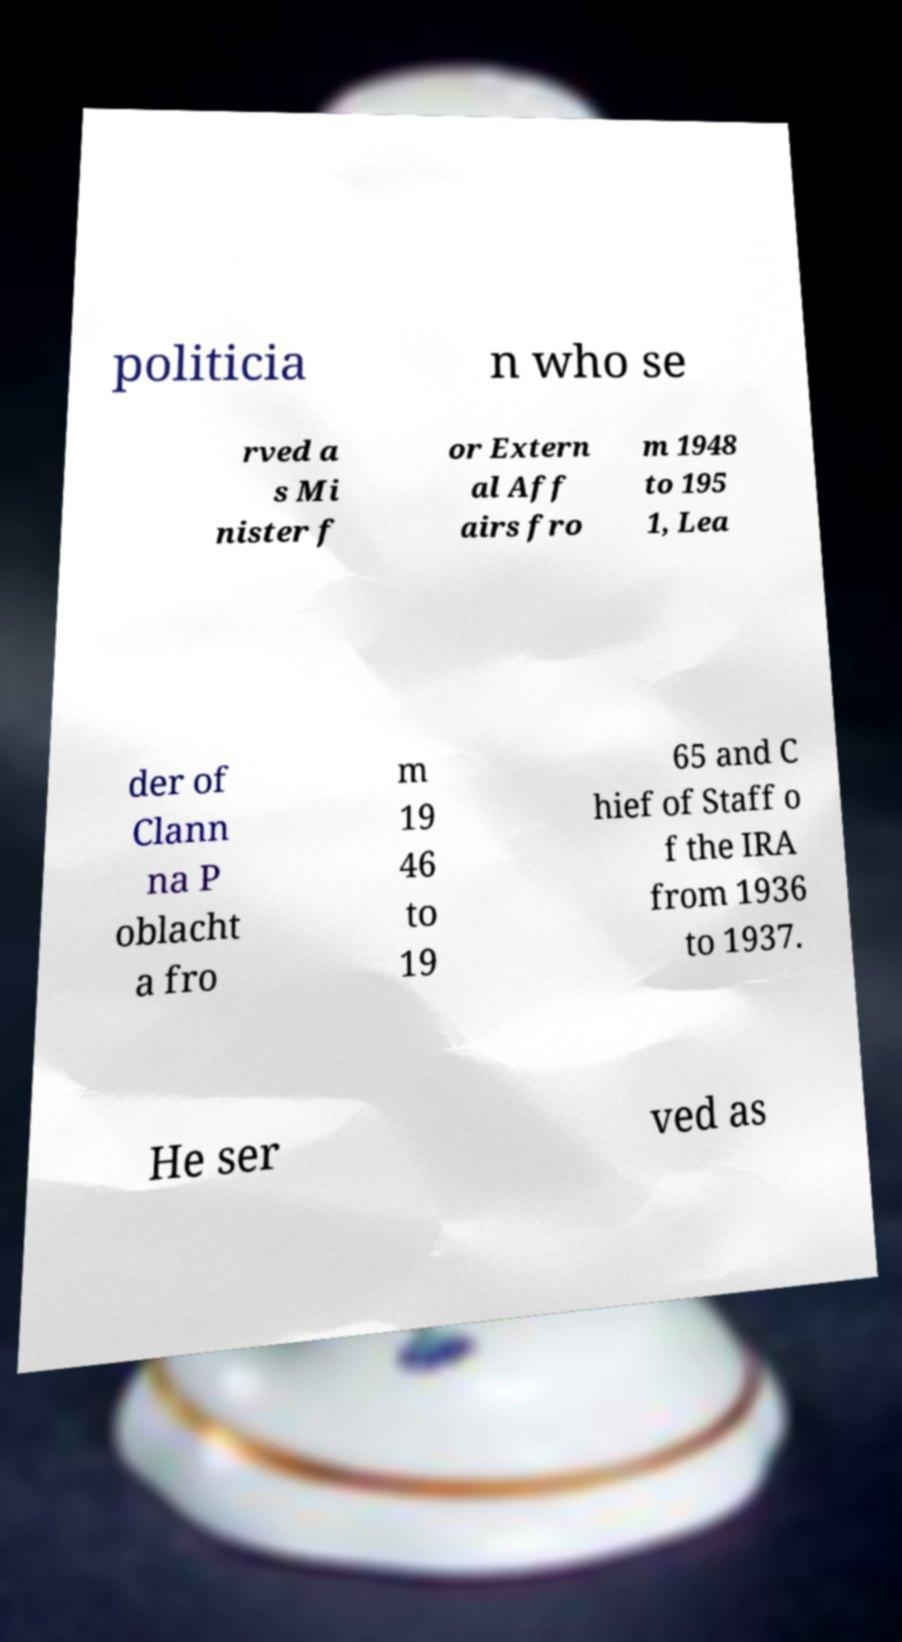Could you extract and type out the text from this image? politicia n who se rved a s Mi nister f or Extern al Aff airs fro m 1948 to 195 1, Lea der of Clann na P oblacht a fro m 19 46 to 19 65 and C hief of Staff o f the IRA from 1936 to 1937. He ser ved as 